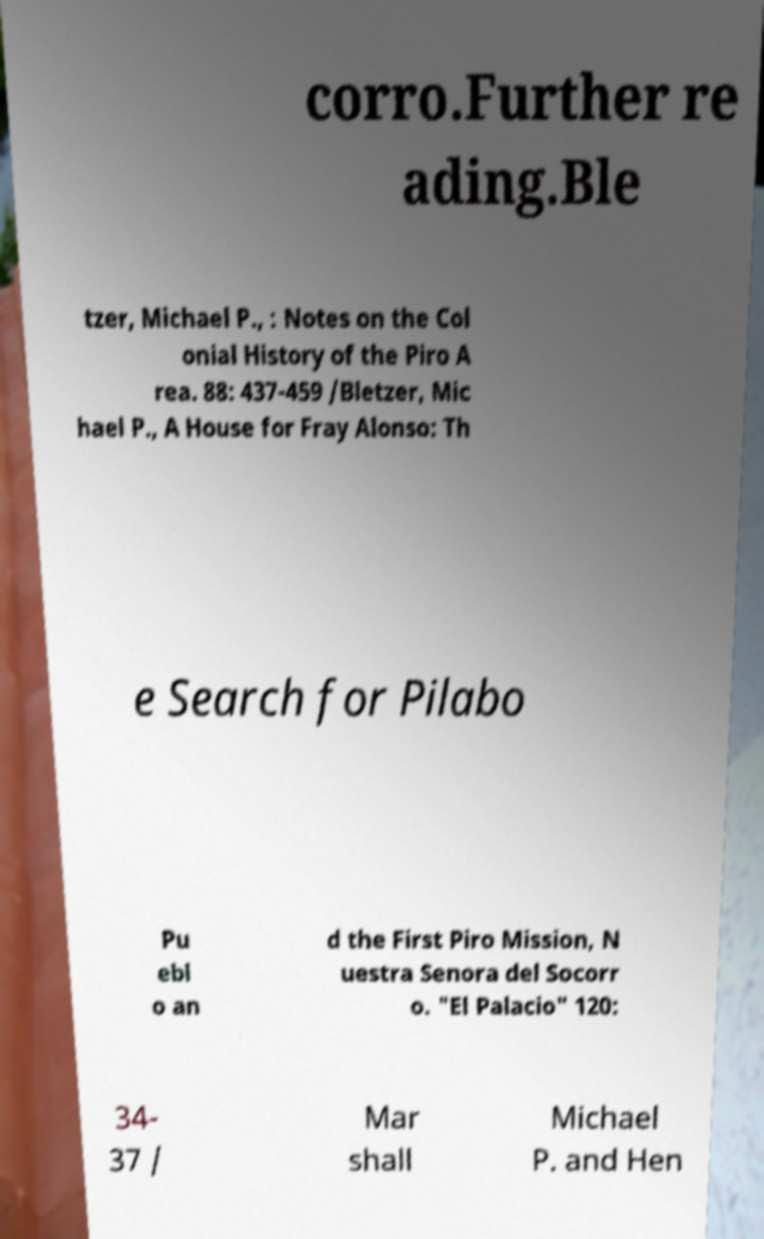Could you assist in decoding the text presented in this image and type it out clearly? corro.Further re ading.Ble tzer, Michael P., : Notes on the Col onial History of the Piro A rea. 88: 437-459 /Bletzer, Mic hael P., A House for Fray Alonso: Th e Search for Pilabo Pu ebl o an d the First Piro Mission, N uestra Senora del Socorr o. "El Palacio" 120: 34- 37 / Mar shall Michael P. and Hen 